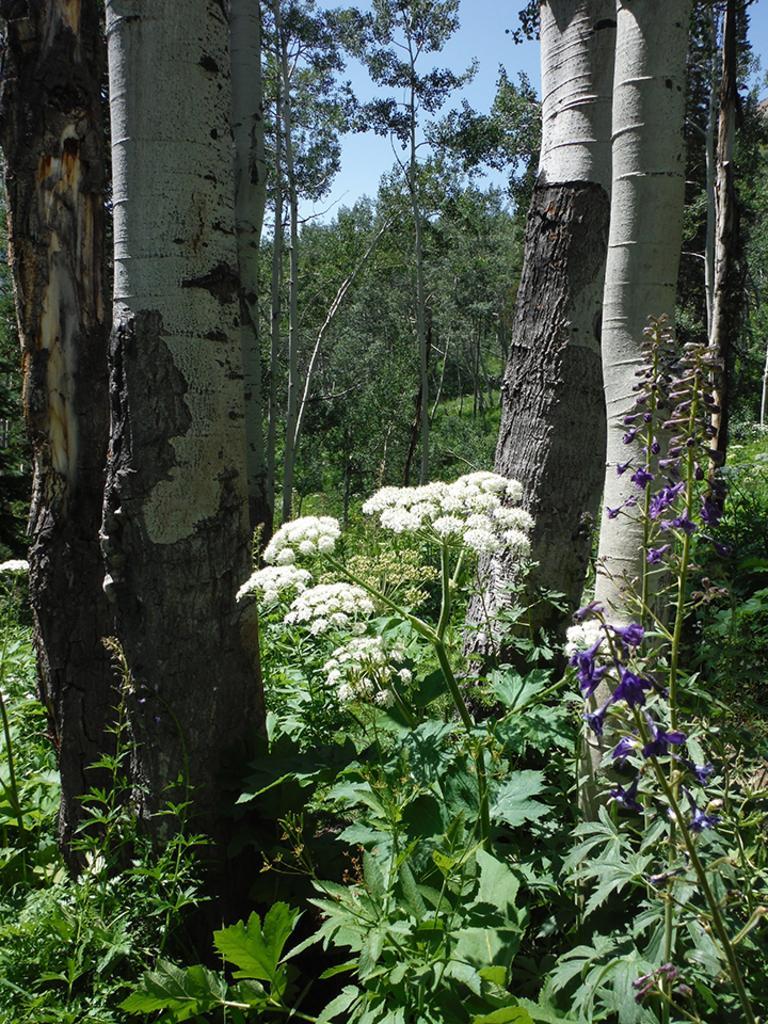Describe this image in one or two sentences. In this picture we can see plants with flowers, trees and in the background we can see the sky. 